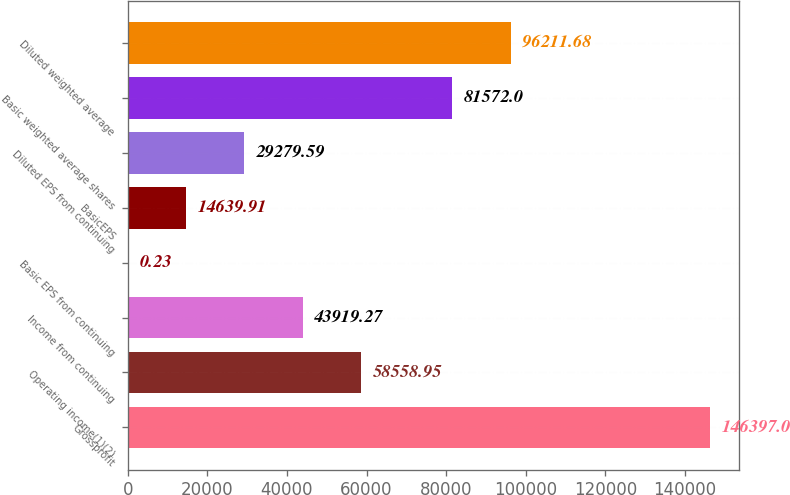<chart> <loc_0><loc_0><loc_500><loc_500><bar_chart><fcel>Grossprofit<fcel>Operating income(1)(2)<fcel>Income from continuing<fcel>Basic EPS from continuing<fcel>BasicEPS<fcel>Diluted EPS from continuing<fcel>Basic weighted average shares<fcel>Diluted weighted average<nl><fcel>146397<fcel>58558.9<fcel>43919.3<fcel>0.23<fcel>14639.9<fcel>29279.6<fcel>81572<fcel>96211.7<nl></chart> 